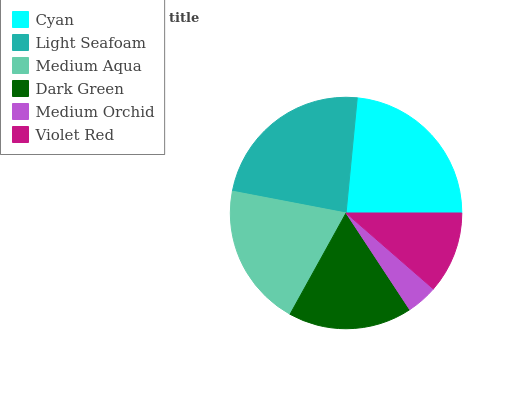Is Medium Orchid the minimum?
Answer yes or no. Yes. Is Light Seafoam the maximum?
Answer yes or no. Yes. Is Medium Aqua the minimum?
Answer yes or no. No. Is Medium Aqua the maximum?
Answer yes or no. No. Is Light Seafoam greater than Medium Aqua?
Answer yes or no. Yes. Is Medium Aqua less than Light Seafoam?
Answer yes or no. Yes. Is Medium Aqua greater than Light Seafoam?
Answer yes or no. No. Is Light Seafoam less than Medium Aqua?
Answer yes or no. No. Is Medium Aqua the high median?
Answer yes or no. Yes. Is Dark Green the low median?
Answer yes or no. Yes. Is Medium Orchid the high median?
Answer yes or no. No. Is Violet Red the low median?
Answer yes or no. No. 